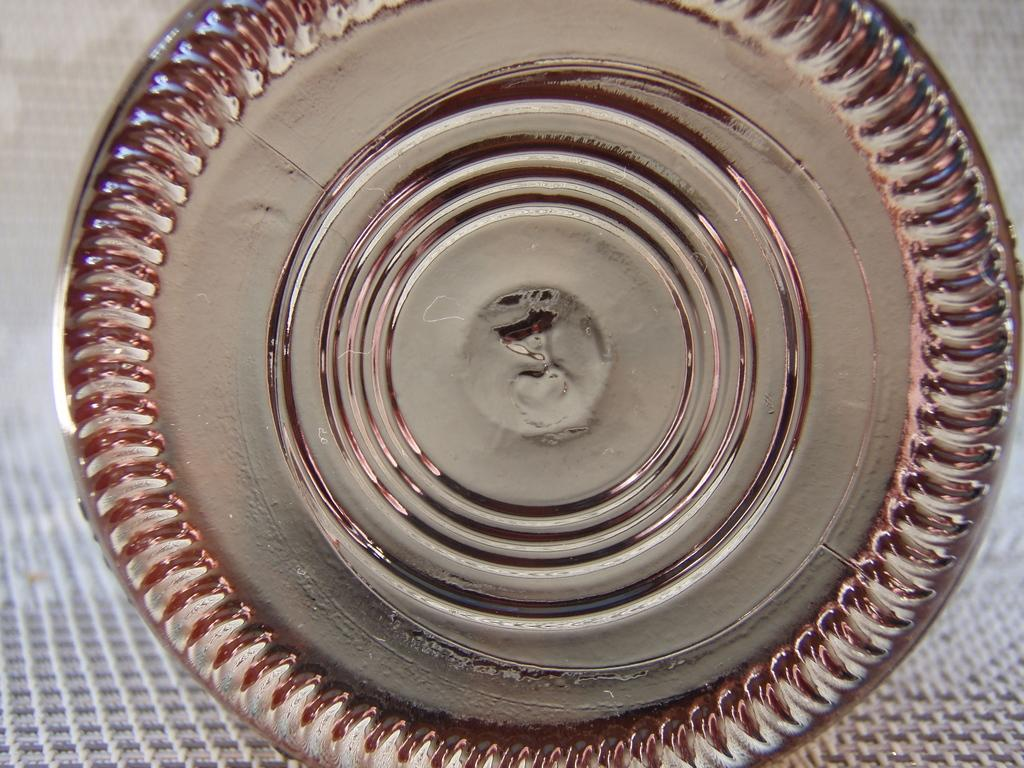What is located in the image? There is a bowl in the image. Where is the bowl placed? The bowl is placed on a mat. What type of knot is tied around the bowl in the image? There is no knot tied around the bowl in the image. Can you see any visible veins on the bowl in the image? The bowl in the image is not a living organism, so it does not have veins. 